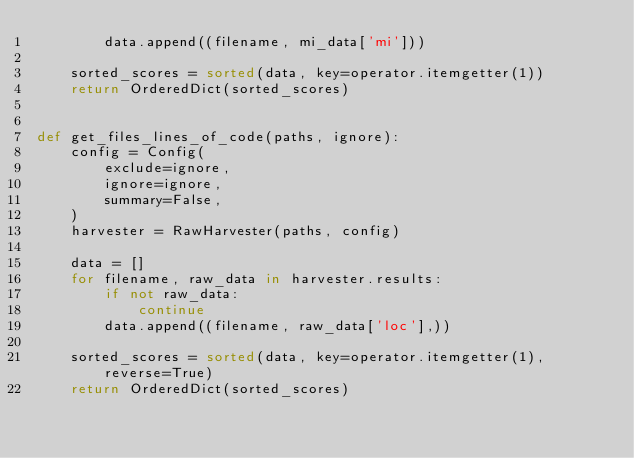<code> <loc_0><loc_0><loc_500><loc_500><_Python_>        data.append((filename, mi_data['mi']))

    sorted_scores = sorted(data, key=operator.itemgetter(1))
    return OrderedDict(sorted_scores)


def get_files_lines_of_code(paths, ignore):
    config = Config(
        exclude=ignore,
        ignore=ignore,
        summary=False,
    )
    harvester = RawHarvester(paths, config)

    data = []
    for filename, raw_data in harvester.results:
        if not raw_data:
            continue
        data.append((filename, raw_data['loc'],))

    sorted_scores = sorted(data, key=operator.itemgetter(1), reverse=True)
    return OrderedDict(sorted_scores)
</code> 